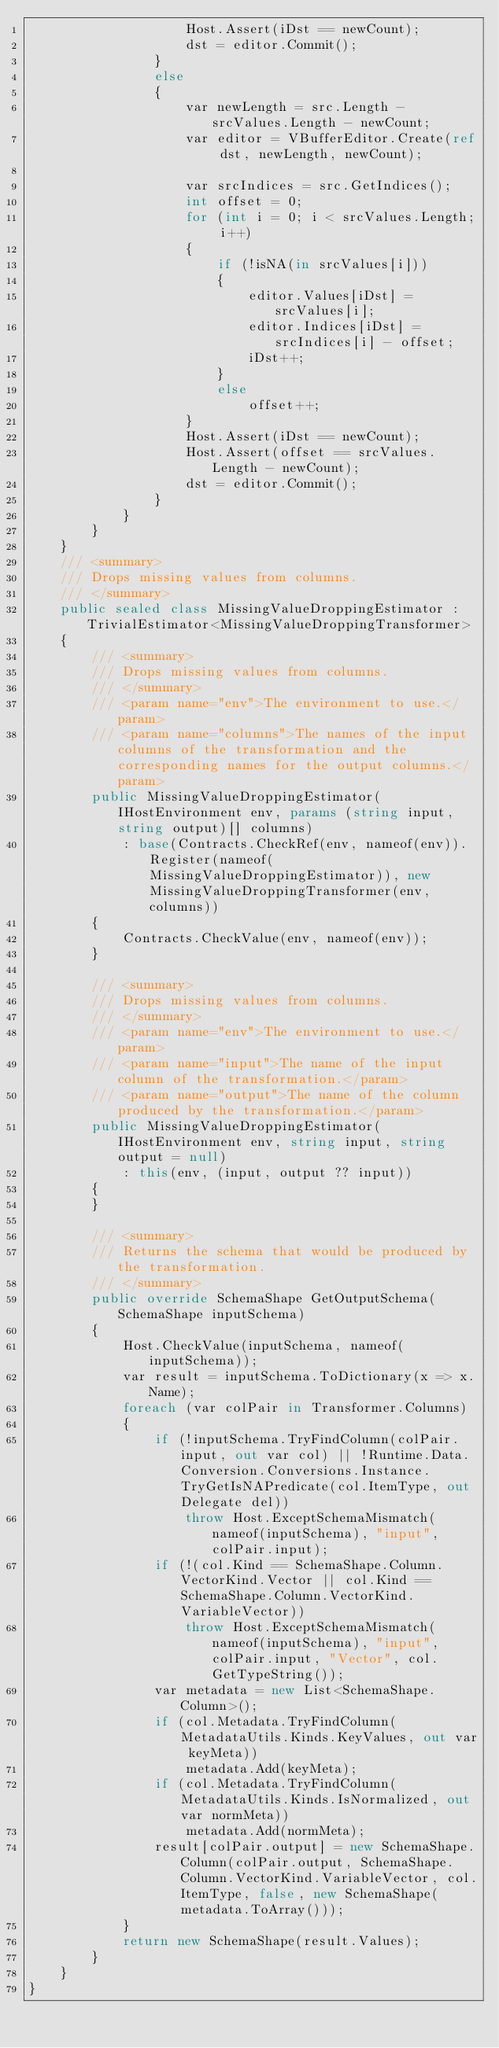<code> <loc_0><loc_0><loc_500><loc_500><_C#_>                    Host.Assert(iDst == newCount);
                    dst = editor.Commit();
                }
                else
                {
                    var newLength = src.Length - srcValues.Length - newCount;
                    var editor = VBufferEditor.Create(ref dst, newLength, newCount);

                    var srcIndices = src.GetIndices();
                    int offset = 0;
                    for (int i = 0; i < srcValues.Length; i++)
                    {
                        if (!isNA(in srcValues[i]))
                        {
                            editor.Values[iDst] = srcValues[i];
                            editor.Indices[iDst] = srcIndices[i] - offset;
                            iDst++;
                        }
                        else
                            offset++;
                    }
                    Host.Assert(iDst == newCount);
                    Host.Assert(offset == srcValues.Length - newCount);
                    dst = editor.Commit();
                }
            }
        }
    }
    /// <summary>
    /// Drops missing values from columns.
    /// </summary>
    public sealed class MissingValueDroppingEstimator : TrivialEstimator<MissingValueDroppingTransformer>
    {
        /// <summary>
        /// Drops missing values from columns.
        /// </summary>
        /// <param name="env">The environment to use.</param>
        /// <param name="columns">The names of the input columns of the transformation and the corresponding names for the output columns.</param>
        public MissingValueDroppingEstimator(IHostEnvironment env, params (string input, string output)[] columns)
            : base(Contracts.CheckRef(env, nameof(env)).Register(nameof(MissingValueDroppingEstimator)), new MissingValueDroppingTransformer(env, columns))
        {
            Contracts.CheckValue(env, nameof(env));
        }

        /// <summary>
        /// Drops missing values from columns.
        /// </summary>
        /// <param name="env">The environment to use.</param>
        /// <param name="input">The name of the input column of the transformation.</param>
        /// <param name="output">The name of the column produced by the transformation.</param>
        public MissingValueDroppingEstimator(IHostEnvironment env, string input, string output = null)
            : this(env, (input, output ?? input))
        {
        }

        /// <summary>
        /// Returns the schema that would be produced by the transformation.
        /// </summary>
        public override SchemaShape GetOutputSchema(SchemaShape inputSchema)
        {
            Host.CheckValue(inputSchema, nameof(inputSchema));
            var result = inputSchema.ToDictionary(x => x.Name);
            foreach (var colPair in Transformer.Columns)
            {
                if (!inputSchema.TryFindColumn(colPair.input, out var col) || !Runtime.Data.Conversion.Conversions.Instance.TryGetIsNAPredicate(col.ItemType, out Delegate del))
                    throw Host.ExceptSchemaMismatch(nameof(inputSchema), "input", colPair.input);
                if (!(col.Kind == SchemaShape.Column.VectorKind.Vector || col.Kind == SchemaShape.Column.VectorKind.VariableVector))
                    throw Host.ExceptSchemaMismatch(nameof(inputSchema), "input", colPair.input, "Vector", col.GetTypeString());
                var metadata = new List<SchemaShape.Column>();
                if (col.Metadata.TryFindColumn(MetadataUtils.Kinds.KeyValues, out var keyMeta))
                    metadata.Add(keyMeta);
                if (col.Metadata.TryFindColumn(MetadataUtils.Kinds.IsNormalized, out var normMeta))
                    metadata.Add(normMeta);
                result[colPair.output] = new SchemaShape.Column(colPair.output, SchemaShape.Column.VectorKind.VariableVector, col.ItemType, false, new SchemaShape(metadata.ToArray()));
            }
            return new SchemaShape(result.Values);
        }
    }
}</code> 